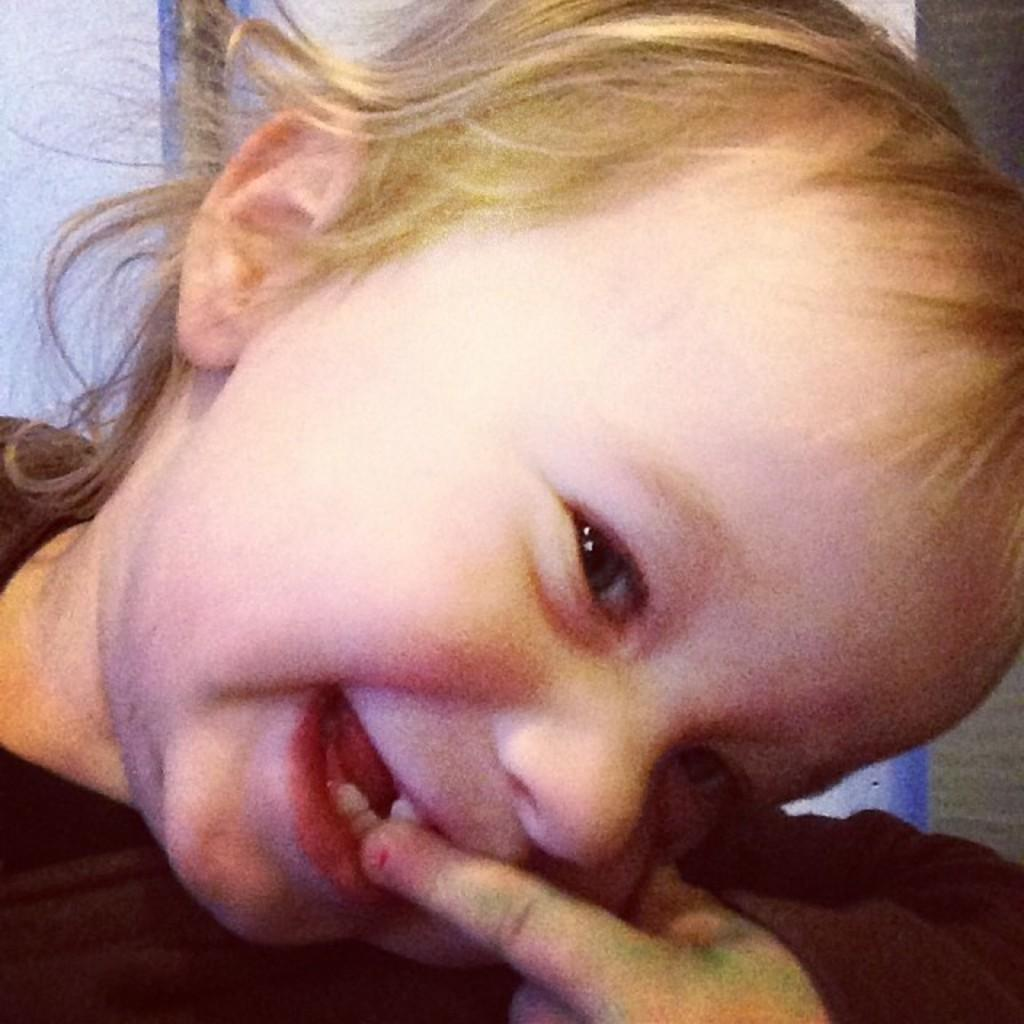What is the main subject in the foreground of the image? There is a kid in the foreground of the image. Can you describe any other elements in the image? Yes, there is a hand visible in the image. How many tomatoes are being used for arithmetic practice in the image? There are no tomatoes or arithmetic practice visible in the image. 